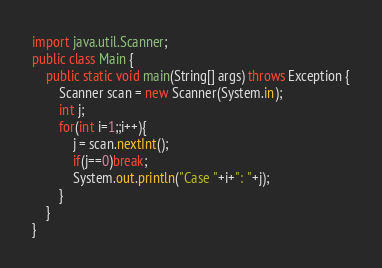Convert code to text. <code><loc_0><loc_0><loc_500><loc_500><_Java_>import java.util.Scanner;
public class Main {
	public static void main(String[] args) throws Exception {
		Scanner scan = new Scanner(System.in);
		int j;
		for(int i=1;;i++){
			j = scan.nextInt();
			if(j==0)break;
			System.out.println("Case "+i+": "+j);
		}
	}
}</code> 